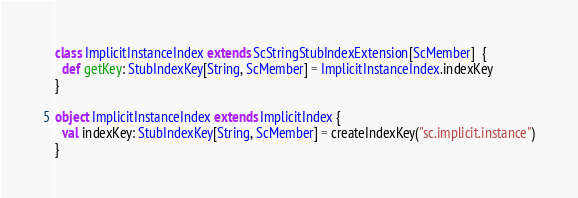<code> <loc_0><loc_0><loc_500><loc_500><_Scala_>class ImplicitInstanceIndex extends ScStringStubIndexExtension[ScMember]  {
  def getKey: StubIndexKey[String, ScMember] = ImplicitInstanceIndex.indexKey
}

object ImplicitInstanceIndex extends ImplicitIndex {
  val indexKey: StubIndexKey[String, ScMember] = createIndexKey("sc.implicit.instance")
}</code> 